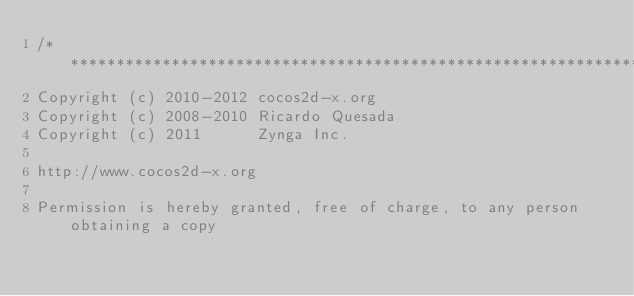Convert code to text. <code><loc_0><loc_0><loc_500><loc_500><_C_>/****************************************************************************
Copyright (c) 2010-2012 cocos2d-x.org
Copyright (c) 2008-2010 Ricardo Quesada
Copyright (c) 2011      Zynga Inc.

http://www.cocos2d-x.org

Permission is hereby granted, free of charge, to any person obtaining a copy</code> 